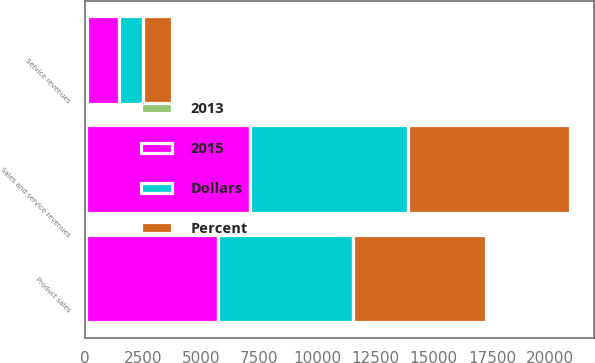<chart> <loc_0><loc_0><loc_500><loc_500><stacked_bar_chart><ecel><fcel>Product sales<fcel>Service revenues<fcel>Sales and service revenues<nl><fcel>2015<fcel>5665<fcel>1355<fcel>7020<nl><fcel>Percent<fcel>5712<fcel>1245<fcel>6957<nl><fcel>Dollars<fcel>5801<fcel>1019<fcel>6820<nl><fcel>2013<fcel>47<fcel>110<fcel>63<nl></chart> 